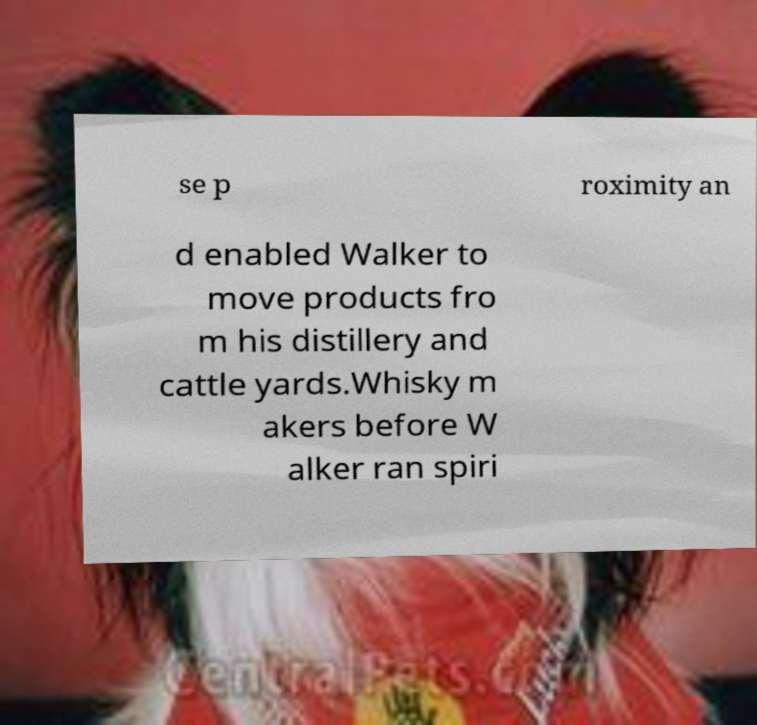Please identify and transcribe the text found in this image. se p roximity an d enabled Walker to move products fro m his distillery and cattle yards.Whisky m akers before W alker ran spiri 